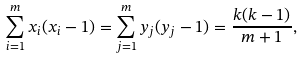Convert formula to latex. <formula><loc_0><loc_0><loc_500><loc_500>\sum _ { i = 1 } ^ { m } x _ { i } ( x _ { i } - 1 ) = \sum _ { j = 1 } ^ { m } y _ { j } ( y _ { j } - 1 ) = \frac { k ( k - 1 ) } { m + 1 } ,</formula> 